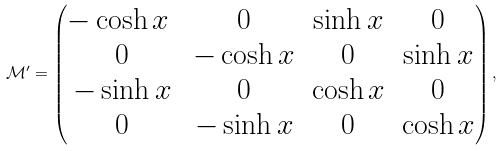<formula> <loc_0><loc_0><loc_500><loc_500>\mathcal { M } ^ { \prime } = \begin{pmatrix} - \cosh x \ & 0 & \sinh x & 0 \\ 0 & - \cosh x & 0 & \sinh x \\ - \sinh x & 0 & \cosh x & 0 \\ 0 & - \sinh x & 0 & \cosh x \end{pmatrix} ,</formula> 